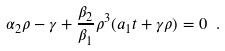<formula> <loc_0><loc_0><loc_500><loc_500>\alpha _ { 2 } \rho - \gamma + \frac { \beta _ { 2 } } { \beta _ { 1 } } \rho ^ { 3 } ( a _ { 1 } t + \gamma \rho ) = 0 \ .</formula> 